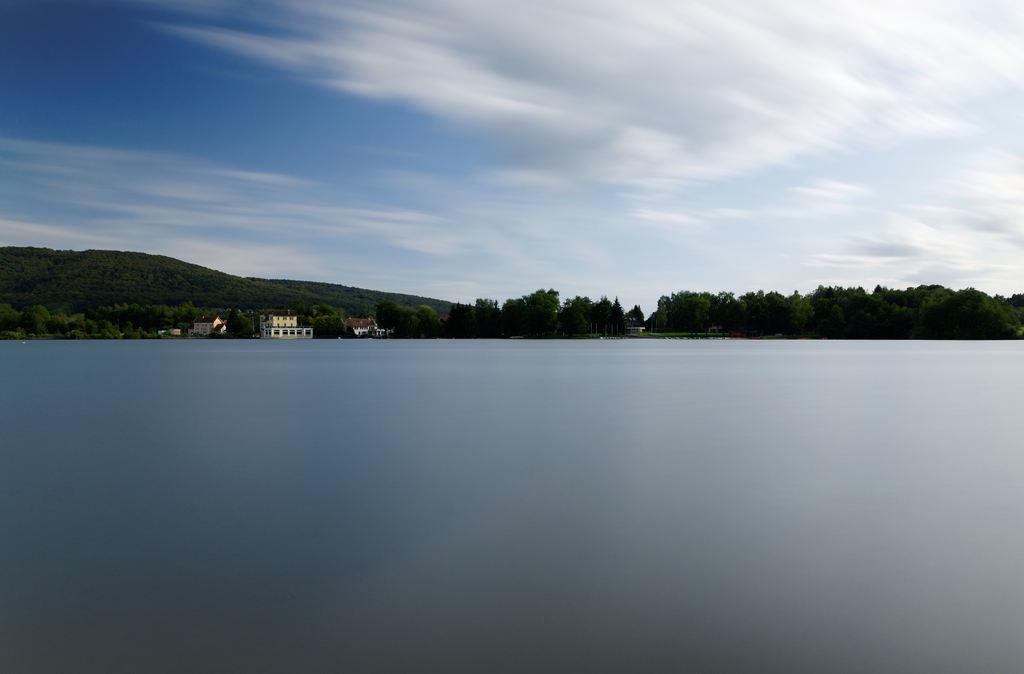In one or two sentences, can you explain what this image depicts? In this image I can see the water. In the background I can see few buildings, few trees, a mountain and the sky. 